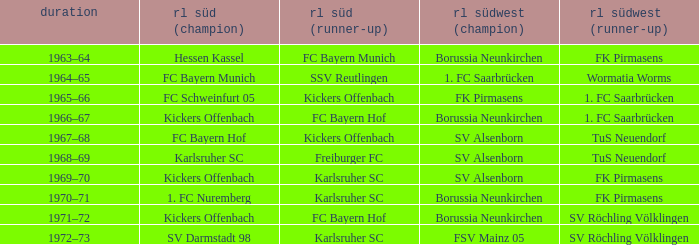Would you be able to parse every entry in this table? {'header': ['duration', 'rl süd (champion)', 'rl süd (runner-up)', 'rl südwest (champion)', 'rl südwest (runner-up)'], 'rows': [['1963–64', 'Hessen Kassel', 'FC Bayern Munich', 'Borussia Neunkirchen', 'FK Pirmasens'], ['1964–65', 'FC Bayern Munich', 'SSV Reutlingen', '1. FC Saarbrücken', 'Wormatia Worms'], ['1965–66', 'FC Schweinfurt 05', 'Kickers Offenbach', 'FK Pirmasens', '1. FC Saarbrücken'], ['1966–67', 'Kickers Offenbach', 'FC Bayern Hof', 'Borussia Neunkirchen', '1. FC Saarbrücken'], ['1967–68', 'FC Bayern Hof', 'Kickers Offenbach', 'SV Alsenborn', 'TuS Neuendorf'], ['1968–69', 'Karlsruher SC', 'Freiburger FC', 'SV Alsenborn', 'TuS Neuendorf'], ['1969–70', 'Kickers Offenbach', 'Karlsruher SC', 'SV Alsenborn', 'FK Pirmasens'], ['1970–71', '1. FC Nuremberg', 'Karlsruher SC', 'Borussia Neunkirchen', 'FK Pirmasens'], ['1971–72', 'Kickers Offenbach', 'FC Bayern Hof', 'Borussia Neunkirchen', 'SV Röchling Völklingen'], ['1972–73', 'SV Darmstadt 98', 'Karlsruher SC', 'FSV Mainz 05', 'SV Röchling Völklingen']]} What season did SV Darmstadt 98 end up at RL Süd (1st)? 1972–73. 